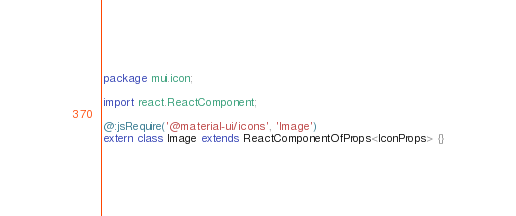<code> <loc_0><loc_0><loc_500><loc_500><_Haxe_>package mui.icon;

import react.ReactComponent;

@:jsRequire('@material-ui/icons', 'Image')
extern class Image extends ReactComponentOfProps<IconProps> {}
</code> 